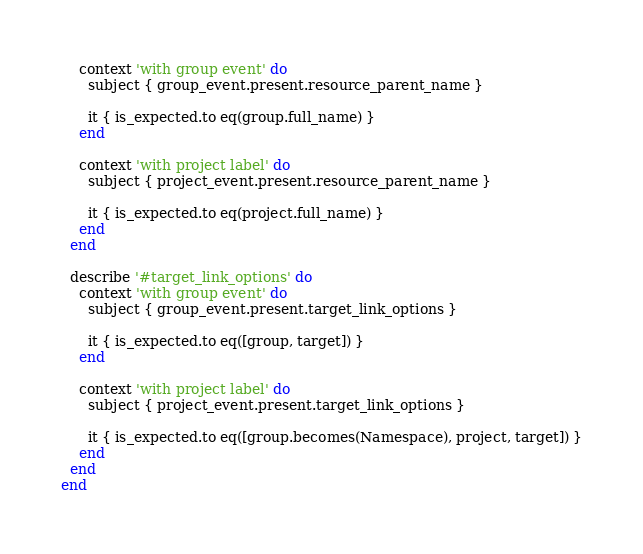<code> <loc_0><loc_0><loc_500><loc_500><_Ruby_>    context 'with group event' do
      subject { group_event.present.resource_parent_name }

      it { is_expected.to eq(group.full_name) }
    end

    context 'with project label' do
      subject { project_event.present.resource_parent_name }

      it { is_expected.to eq(project.full_name) }
    end
  end

  describe '#target_link_options' do
    context 'with group event' do
      subject { group_event.present.target_link_options }

      it { is_expected.to eq([group, target]) }
    end

    context 'with project label' do
      subject { project_event.present.target_link_options }

      it { is_expected.to eq([group.becomes(Namespace), project, target]) }
    end
  end
end
</code> 